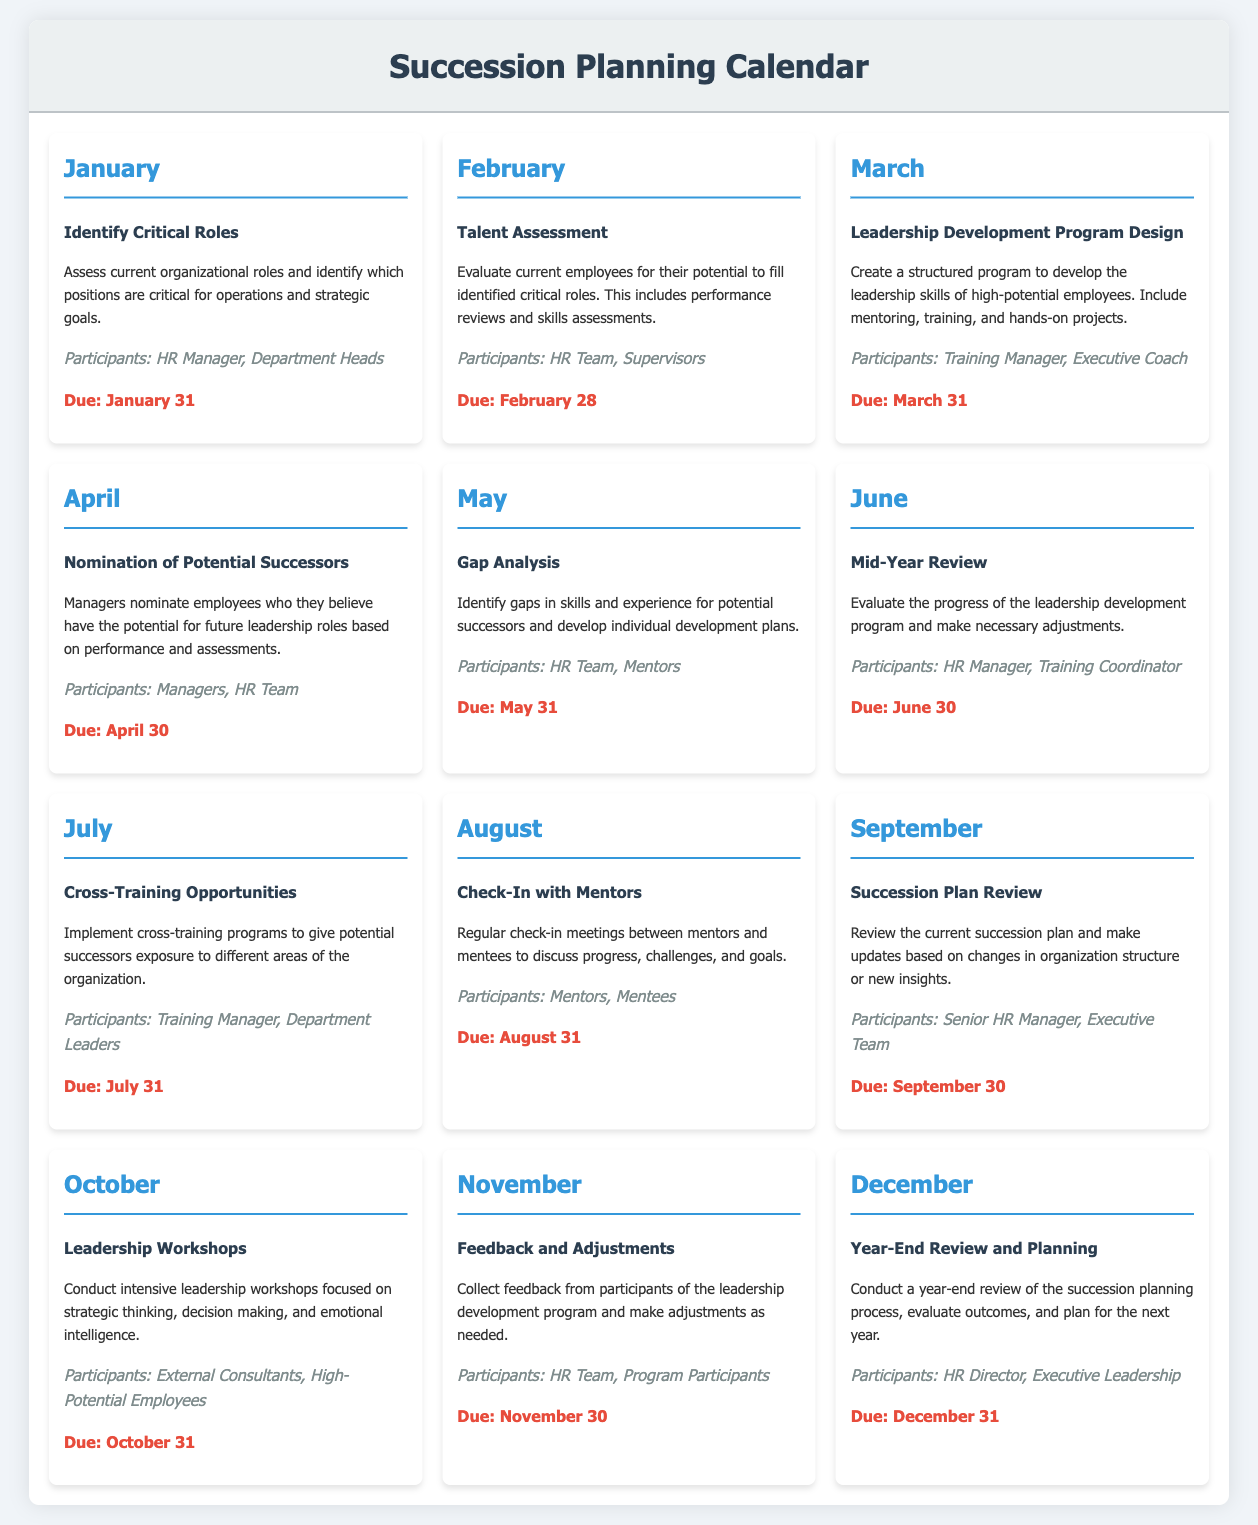What is the task for January? The document states that the task for January is to "Identify Critical Roles."
Answer: Identify Critical Roles Who are the participants for the April task? The participants for the April task, "Nomination of Potential Successors," are identified in the document.
Answer: Managers, HR Team What is the due date for the Talent Assessment task? The due date for the February task "Talent Assessment" is explicitly mentioned in the document.
Answer: February 28 How many leadership workshops are scheduled in October? There is only one task scheduled for October as outlined in the document.
Answer: One Which month includes a Mid-Year Review? The document lists the task "Mid-Year Review" under a specific month, which is necessary to answer.
Answer: June What type of program is scheduled for March? The task for March involves creating a specific type of program mentioned in the document.
Answer: Leadership Development Program What will happen in November regarding the leadership development program? The document explains that feedback will be collected in November related to the program.
Answer: Feedback and Adjustments Who is responsible for the Year-End Review in December? The document states who will participate in the year-end review specified under the December task.
Answer: HR Director, Executive Leadership 